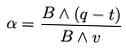<formula> <loc_0><loc_0><loc_500><loc_500>\alpha = \frac { B \wedge ( q - t ) } { B \wedge v }</formula> 